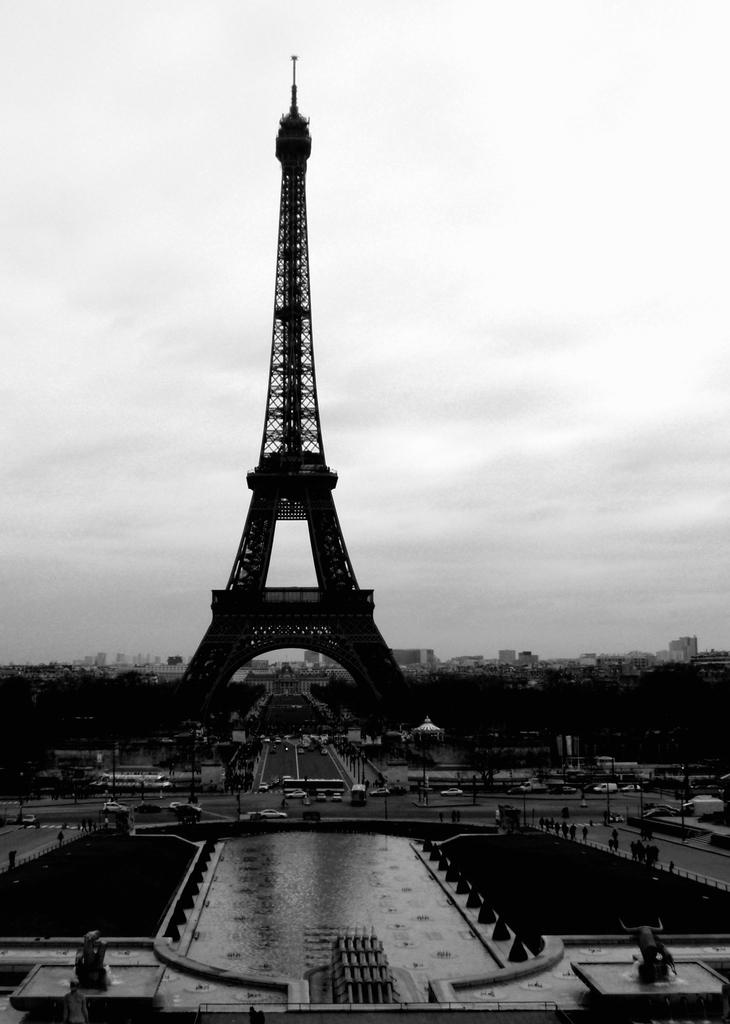What famous landmark can be seen in the image? The Eiffel tower is visible in the image. What type of transportation infrastructure is present in the image? There are: There are roads in the image. What are some of the vehicles that can be seen in the image? Vehicles are present in the image. What type of natural elements can be seen in the image? Trees are visible in the image. What type of man-made structures are present in the image? Buildings are present in the image. What type of water feature can be seen in the image? There is water visible in the image. What can be seen in the background of the image? The sky is visible in the background of the image. How many sisters are playing with balls in the image? There are no sisters or balls present in the image. What type of cast can be seen on the person in the image? There is no person with a cast present in the image. 